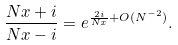<formula> <loc_0><loc_0><loc_500><loc_500>\frac { N x + i } { N x - i } = e ^ { \frac { 2 i } { N x } + O ( N ^ { - 2 } ) } .</formula> 